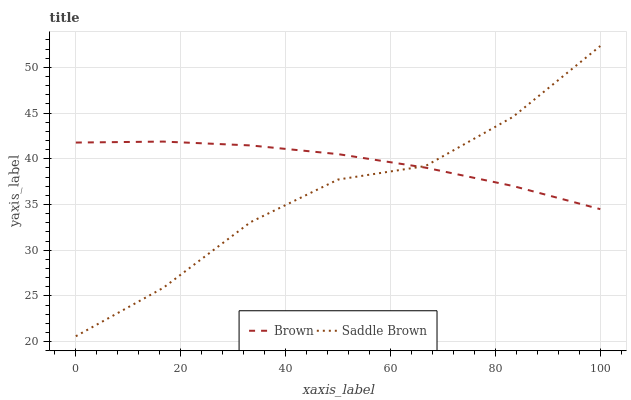Does Saddle Brown have the minimum area under the curve?
Answer yes or no. Yes. Does Brown have the maximum area under the curve?
Answer yes or no. Yes. Does Saddle Brown have the maximum area under the curve?
Answer yes or no. No. Is Brown the smoothest?
Answer yes or no. Yes. Is Saddle Brown the roughest?
Answer yes or no. Yes. Is Saddle Brown the smoothest?
Answer yes or no. No. Does Saddle Brown have the highest value?
Answer yes or no. Yes. Does Saddle Brown intersect Brown?
Answer yes or no. Yes. Is Saddle Brown less than Brown?
Answer yes or no. No. Is Saddle Brown greater than Brown?
Answer yes or no. No. 